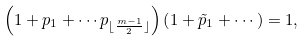Convert formula to latex. <formula><loc_0><loc_0><loc_500><loc_500>\left ( 1 + p _ { 1 } + \cdots p _ { \lfloor \frac { m - 1 } { 2 } \rfloor } \right ) \left ( 1 + \tilde { p } _ { 1 } + \cdots \right ) = 1 ,</formula> 